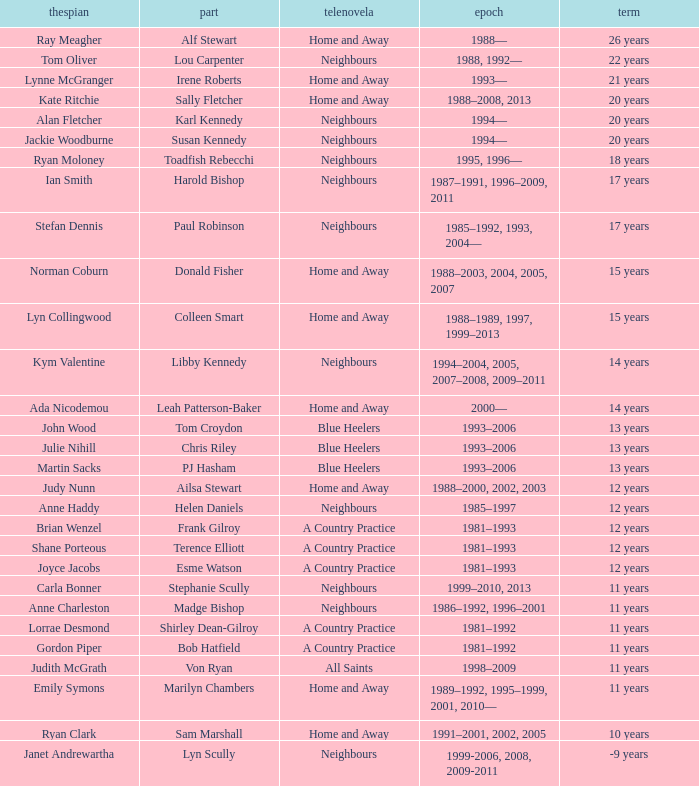What was the length of time joyce jacobs spent portraying her part on the show? 12 years. 